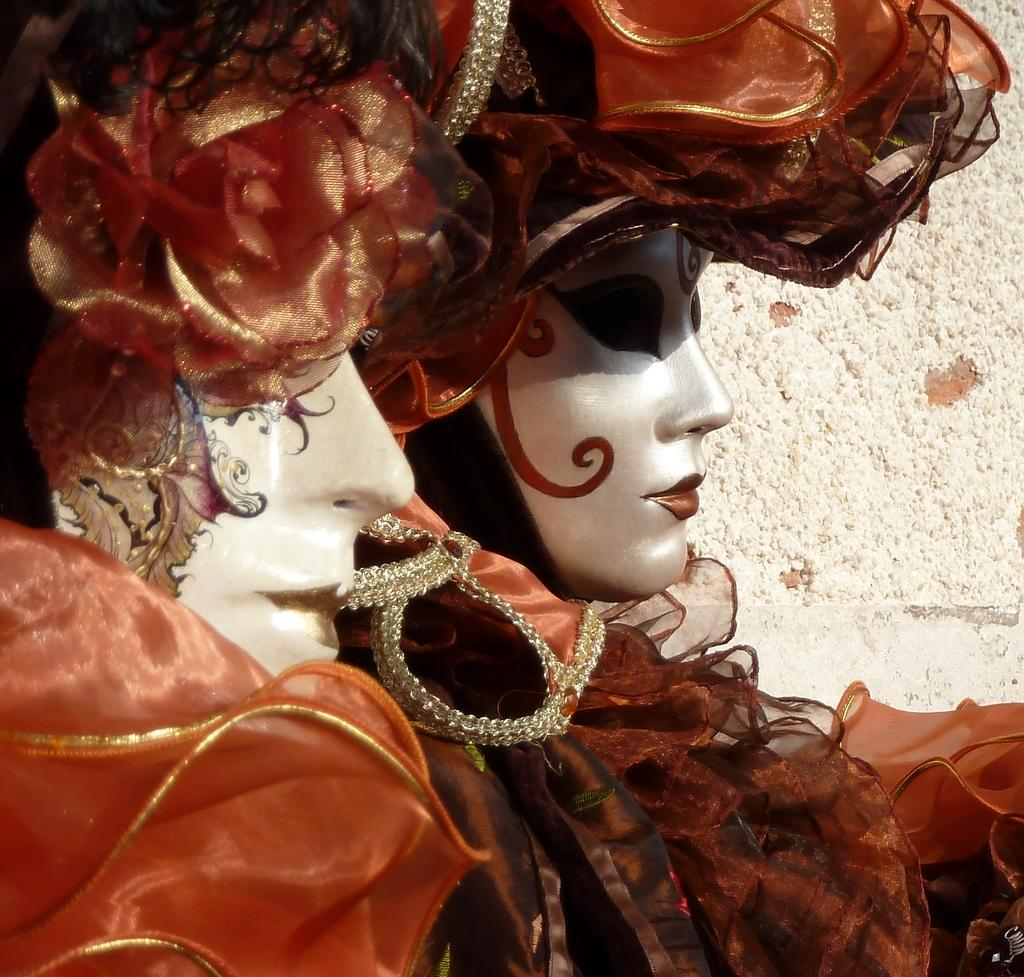How many people are on the left side of the image? There are two persons on the left side of the image. What are the people wearing? The persons are wearing orange color dresses. Can you describe any additional features of the people? The persons have makeup. What color is the surface in the background of the image? The surface in the background of the image is white. What type of glue is being used by the persons in the image? There is no indication in the image that the persons are using glue, so it cannot be determined from the picture. 